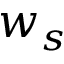<formula> <loc_0><loc_0><loc_500><loc_500>w _ { s }</formula> 